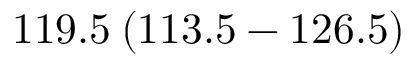Convert formula to latex. <formula><loc_0><loc_0><loc_500><loc_500>1 1 9 . 5 \, ( 1 1 3 . 5 - 1 2 6 . 5 )</formula> 